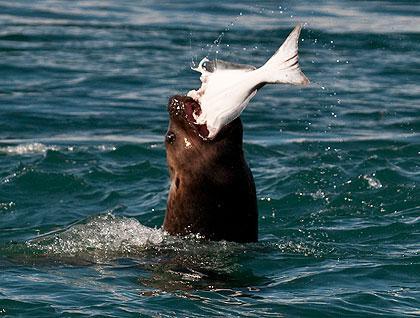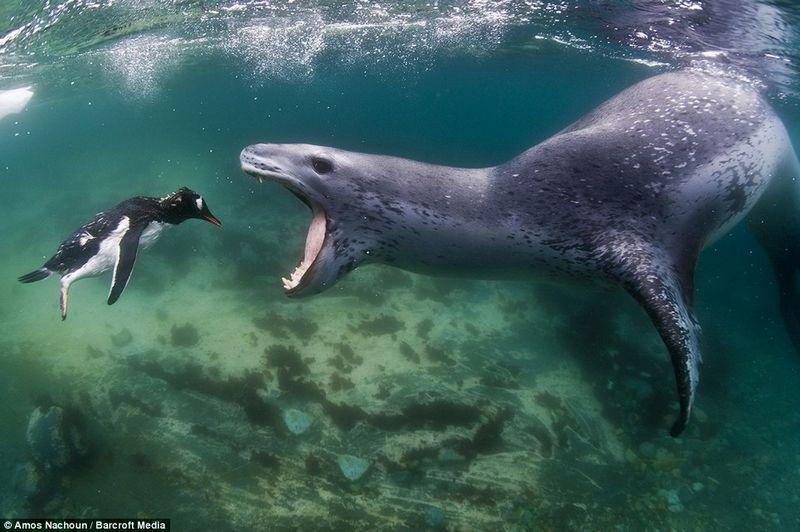The first image is the image on the left, the second image is the image on the right. For the images displayed, is the sentence "a seal with a mouth wide open is trying to catch a penguin" factually correct? Answer yes or no. Yes. 